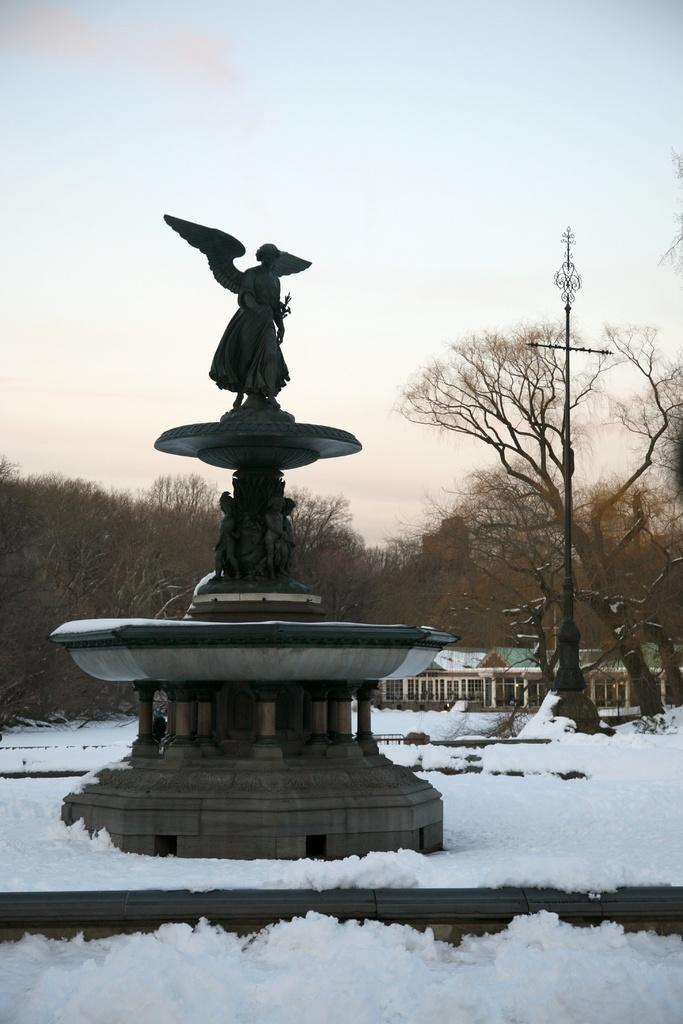What type of objects can be seen in the image? There are statues in the image. What is the weather like in the image? There is snow in the image, indicating a cold and wintry scene. What structure is present in the image? There is a pole in the image. What type of building can be seen in the image? There is a shed in the image. What type of vegetation is present in the image? There are trees in the image. What is visible in the background of the image? The sky is visible in the background of the image. Can you tell me how many crows are perched on the statues in the image? There are no crows present in the image; it only features statues, snow, a pole, a shed, trees, and the sky. Where are the kittens playing in the image? There are no kittens present in the image. 